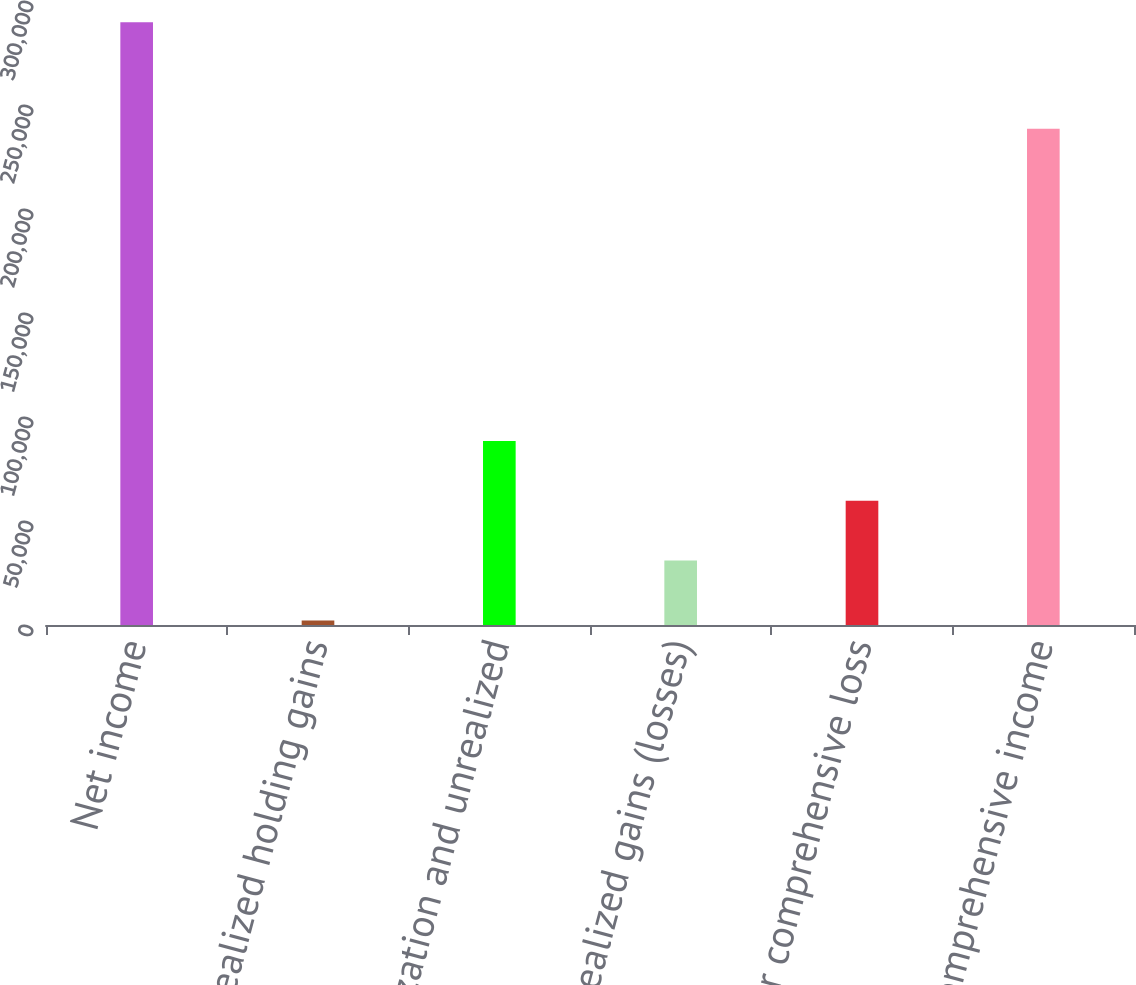Convert chart to OTSL. <chart><loc_0><loc_0><loc_500><loc_500><bar_chart><fcel>Net income<fcel>Net unrealized holding gains<fcel>Amortization and unrealized<fcel>Net unrealized gains (losses)<fcel>Total other comprehensive loss<fcel>Total comprehensive income<nl><fcel>289817<fcel>2214<fcel>88494.9<fcel>30974.3<fcel>59734.6<fcel>238546<nl></chart> 